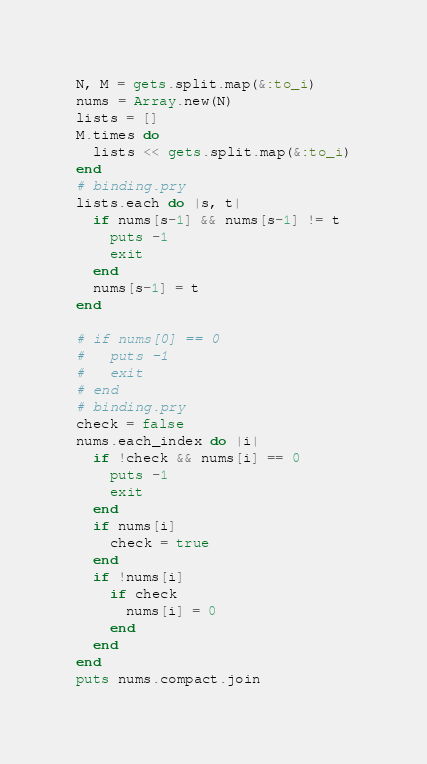<code> <loc_0><loc_0><loc_500><loc_500><_Ruby_>N, M = gets.split.map(&:to_i)
nums = Array.new(N)
lists = []
M.times do
  lists << gets.split.map(&:to_i)
end
# binding.pry
lists.each do |s, t|
  if nums[s-1] && nums[s-1] != t
    puts -1
    exit
  end
  nums[s-1] = t
end

# if nums[0] == 0
#   puts -1
#   exit
# end
# binding.pry
check = false
nums.each_index do |i|
  if !check && nums[i] == 0
    puts -1
    exit
  end
  if nums[i]
    check = true
  end
  if !nums[i]
    if check
      nums[i] = 0
    end
  end
end
puts nums.compact.join</code> 